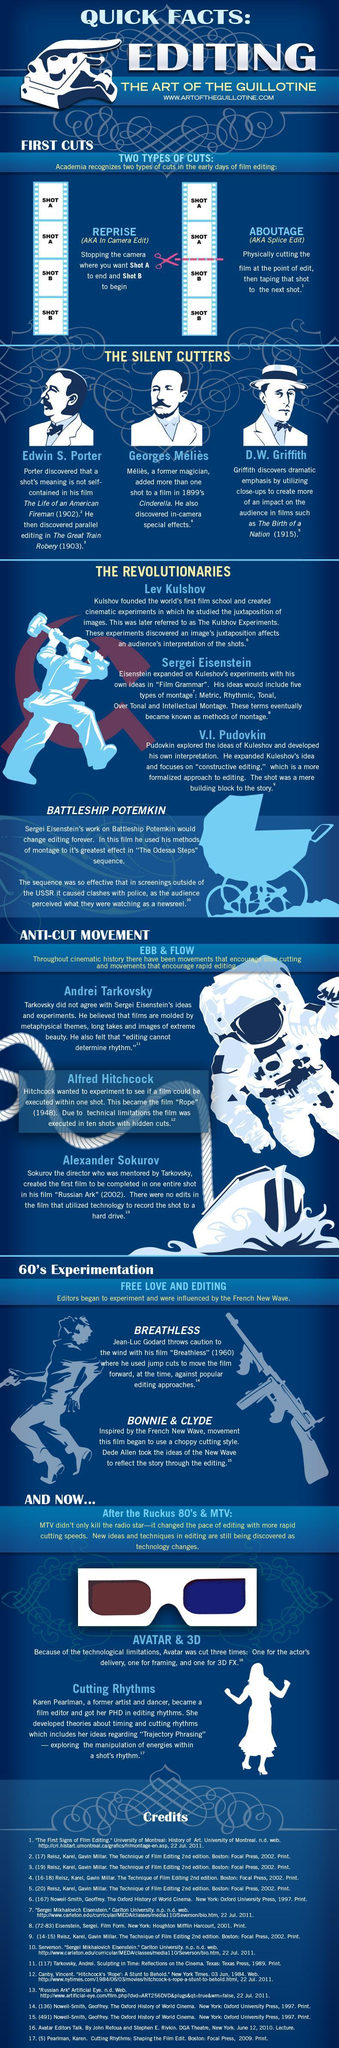In which movie "jump cuts" were used to make the film shift down?
Answer the question with a short phrase. Breathless In which film more than a single shot has included? Cinderella Which is the movie where parallel editing has done? The Great Train Robery Which are the two different types of movie editing cuts? Reprise, Aboutage For what the second cut of movie Avatar was done? framing 